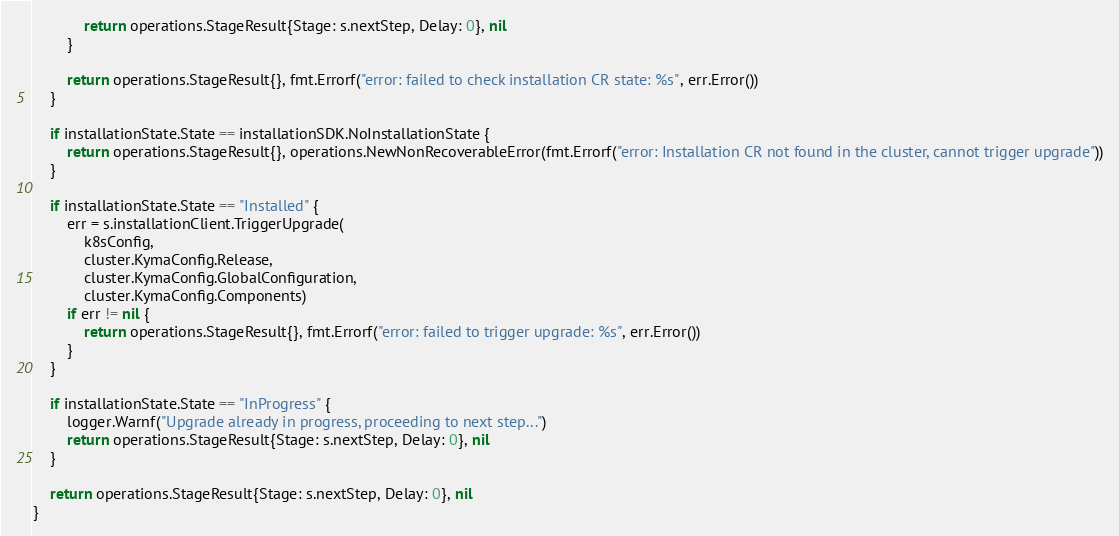<code> <loc_0><loc_0><loc_500><loc_500><_Go_>			return operations.StageResult{Stage: s.nextStep, Delay: 0}, nil
		}

		return operations.StageResult{}, fmt.Errorf("error: failed to check installation CR state: %s", err.Error())
	}

	if installationState.State == installationSDK.NoInstallationState {
		return operations.StageResult{}, operations.NewNonRecoverableError(fmt.Errorf("error: Installation CR not found in the cluster, cannot trigger upgrade"))
	}

	if installationState.State == "Installed" {
		err = s.installationClient.TriggerUpgrade(
			k8sConfig,
			cluster.KymaConfig.Release,
			cluster.KymaConfig.GlobalConfiguration,
			cluster.KymaConfig.Components)
		if err != nil {
			return operations.StageResult{}, fmt.Errorf("error: failed to trigger upgrade: %s", err.Error())
		}
	}

	if installationState.State == "InProgress" {
		logger.Warnf("Upgrade already in progress, proceeding to next step...")
		return operations.StageResult{Stage: s.nextStep, Delay: 0}, nil
	}

	return operations.StageResult{Stage: s.nextStep, Delay: 0}, nil
}
</code> 